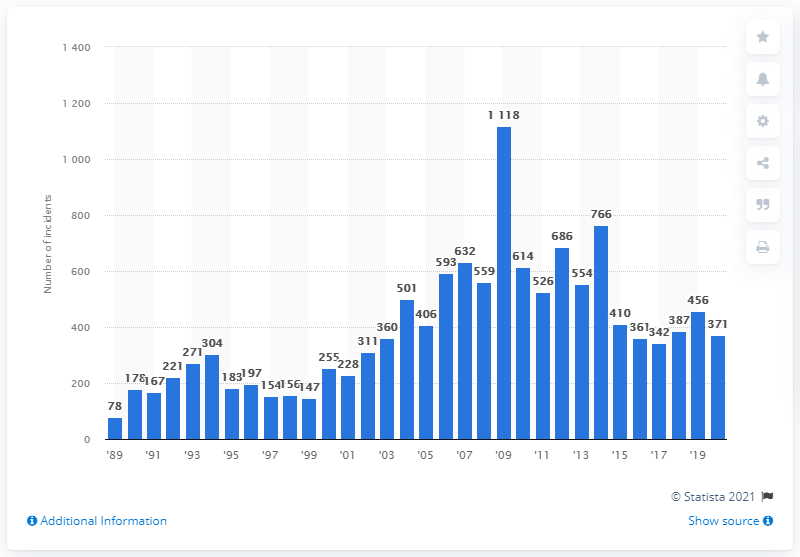Draw attention to some important aspects in this diagram. In 2020, there were 371 reported cases of violent anti-Semitism worldwide. In 2019, there were 456 cases of violent anti-Semitism. 